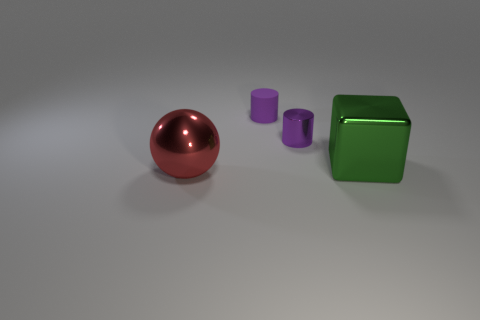What color is the big object that is behind the big shiny object in front of the large thing that is right of the big red metal thing?
Your response must be concise. Green. Is the material of the green block the same as the cylinder that is behind the tiny purple shiny cylinder?
Offer a terse response. No. There is another object that is the same shape as the matte thing; what is its size?
Provide a succinct answer. Small. Are there the same number of purple cylinders that are in front of the large red thing and large green shiny blocks that are in front of the green metal block?
Give a very brief answer. Yes. How many other objects are the same material as the big green block?
Provide a succinct answer. 2. Is the number of shiny objects that are right of the big red metallic sphere the same as the number of large blocks?
Ensure brevity in your answer.  No. Does the shiny cylinder have the same size as the metal thing that is in front of the green thing?
Keep it short and to the point. No. The big shiny object to the left of the big block has what shape?
Ensure brevity in your answer.  Sphere. Is there anything else that is the same shape as the green thing?
Provide a short and direct response. No. Are there any gray matte spheres?
Ensure brevity in your answer.  No. 